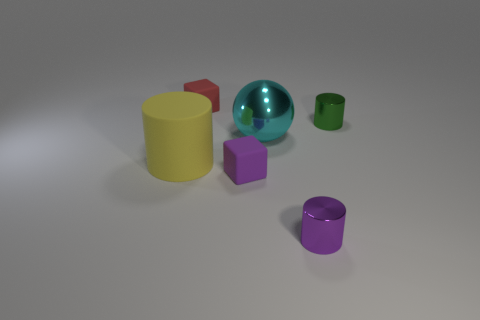Add 1 yellow objects. How many objects exist? 7 Subtract all spheres. How many objects are left? 5 Add 5 large cyan metal things. How many large cyan metal things are left? 6 Add 5 green objects. How many green objects exist? 6 Subtract 0 blue balls. How many objects are left? 6 Subtract all tiny purple metallic cylinders. Subtract all red cubes. How many objects are left? 4 